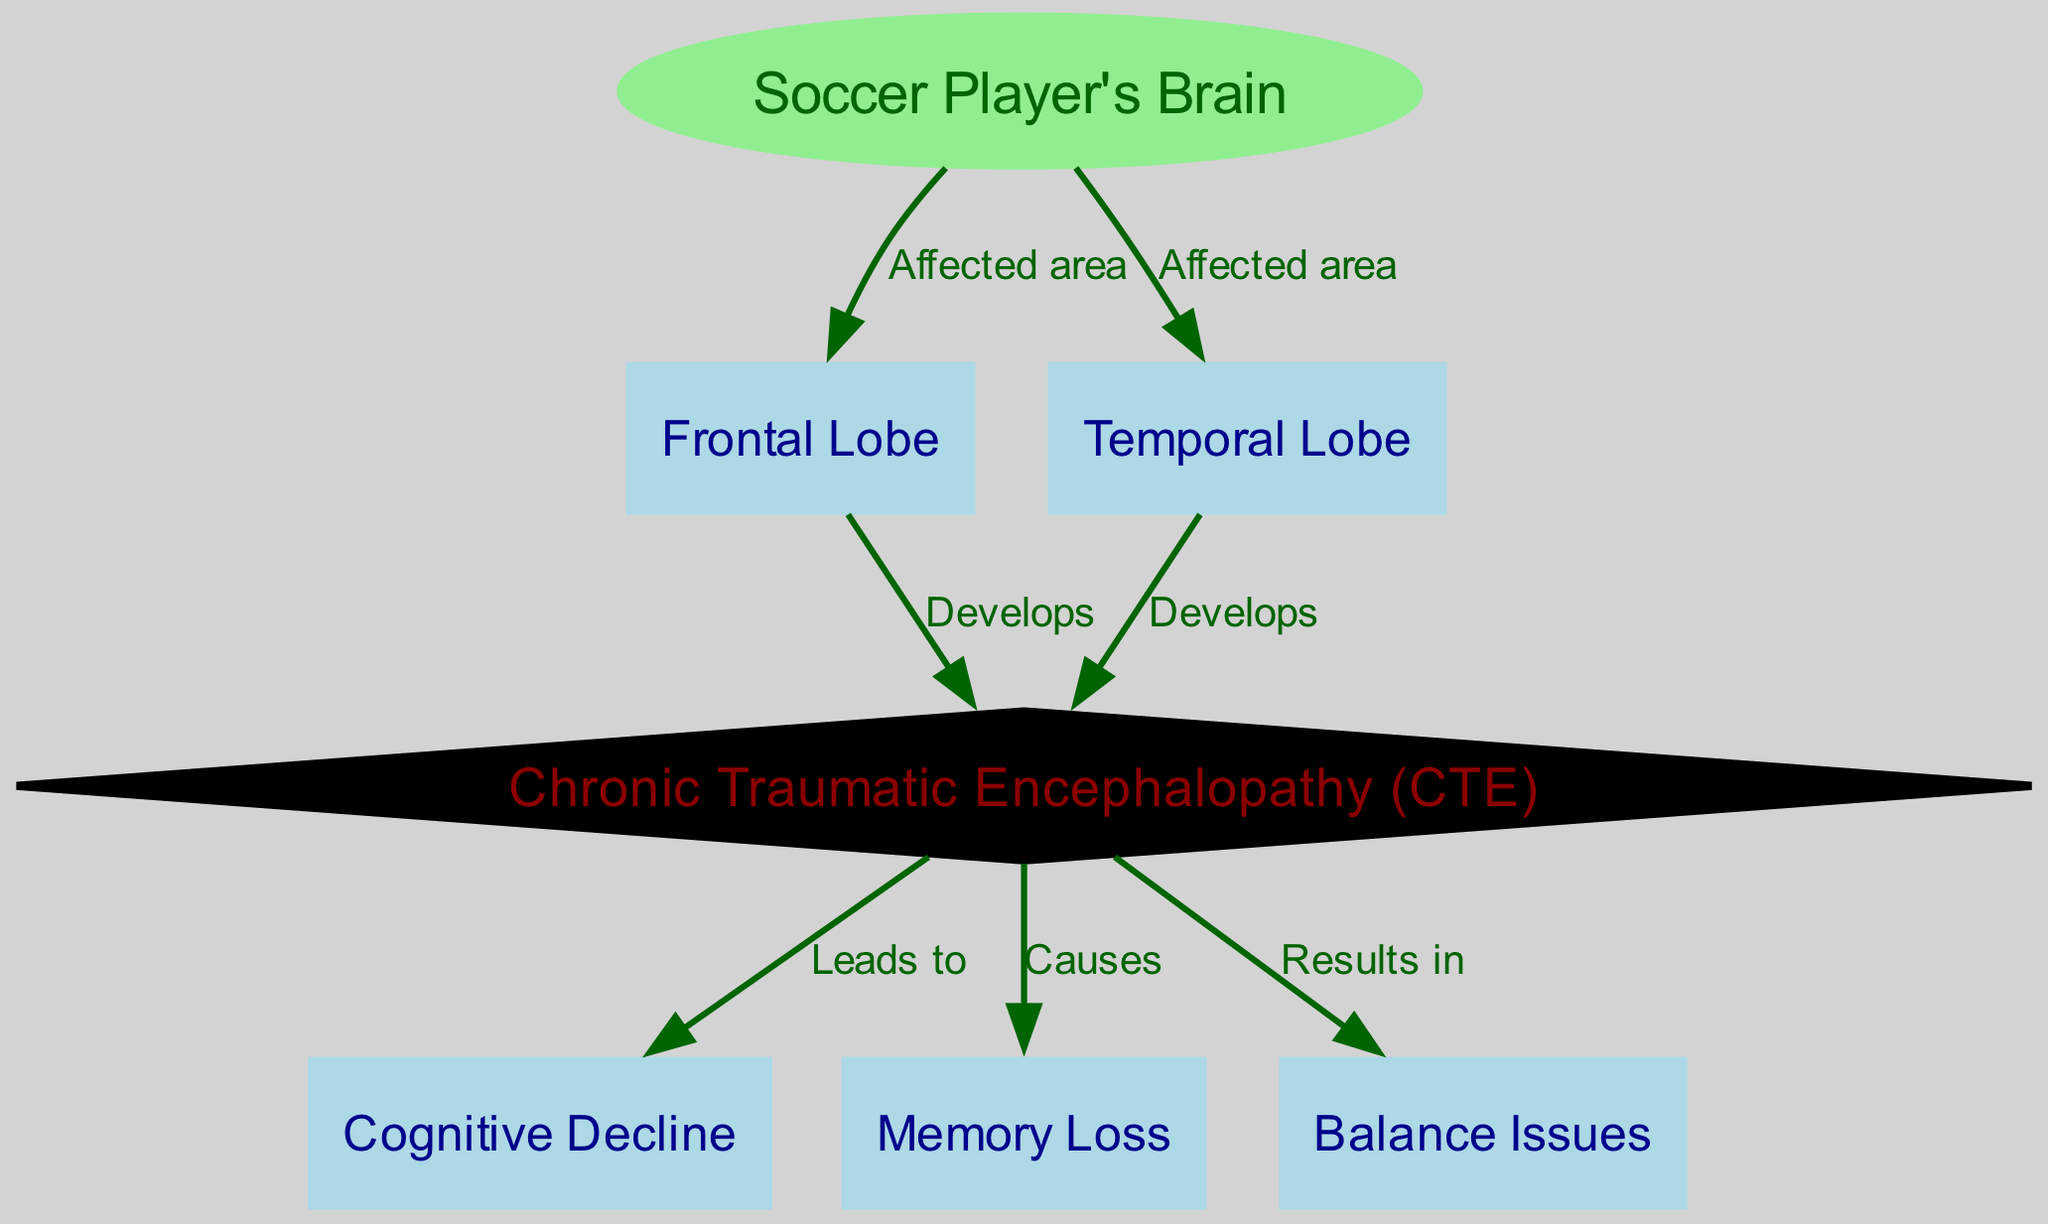What is the primary affected area in the brain according to the diagram? The diagram indicates that both the frontal lobe and temporal lobe are affected areas of the soccer player's brain. Since the question asks for the primary area, either can be reasonable, but the frontal lobe is typically associated with higher cognitive functions and is often emphasized in studies related to sports injuries.
Answer: Frontal Lobe How many nodes are present in the diagram? To determine the total number of nodes, we count all the unique nodes including the soccer player's brain and specific regions or conditions related to it. There are a total of 7 nodes represented in the diagram.
Answer: 7 What condition develops from the frontal lobe? The diagram specifies a direct relationship indicating that the frontal lobe leads to the development of Chronic Traumatic Encephalopathy (CTE). This shows that CTE is linked to damage in the frontal lobe due to repetitive heading.
Answer: Chronic Traumatic Encephalopathy (CTE) What are the three outcomes of Chronic Traumatic Encephalopathy (CTE)? The diagram clearly shows that CTE leads to cognitive decline and causes memory loss, as well as results in balance issues. Therefore, all three outcomes can be derived directly from the connections in the diagram.
Answer: Cognitive Decline, Memory Loss, Balance Issues How does the temporal lobe relate to Chronic Traumatic Encephalopathy (CTE)? The diagram indicates that the temporal lobe also develops Chronic Traumatic Encephalopathy (CTE), shown by the direct connection from the temporal lobe to the CTE node. This showcases the temporal lobe's involvement in the same condition affecting the frontal lobe.
Answer: Develops What is the consequence of Chronic Traumatic Encephalopathy (CTE)? The diagram illustrates that CTE leads to cognitive decline, causes memory loss, and results in balance issues. Therefore, the consequences of CTE are directly shown and can be easily identified.
Answer: Cognitive Decline, Memory Loss, Balance Issues 